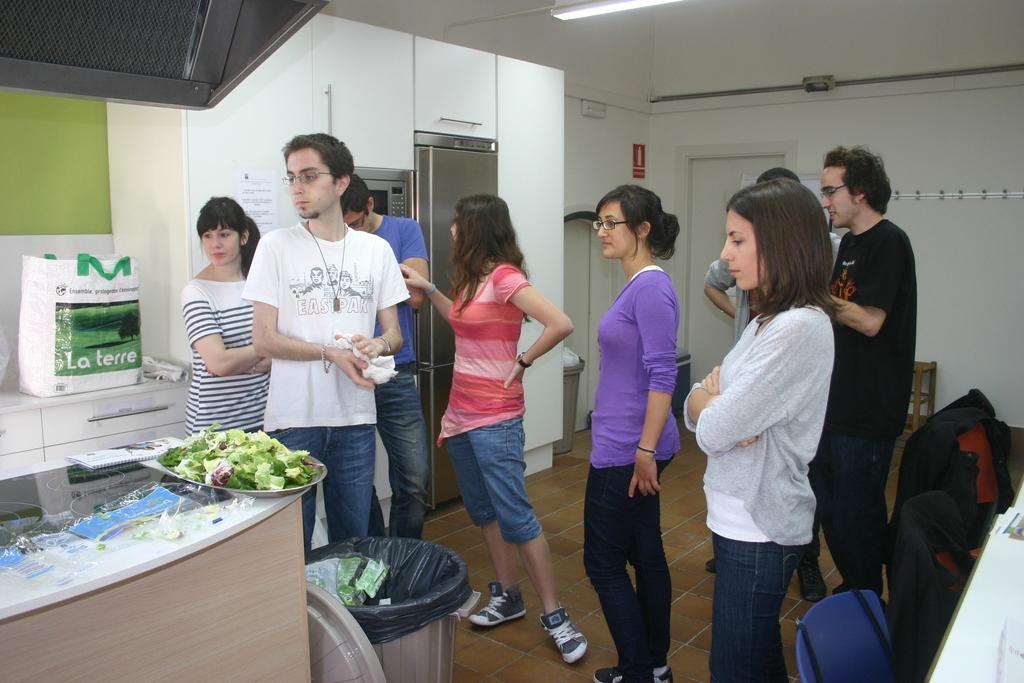Describe this image in one or two sentences. This picture is clicked inside the room. In this picture, we see many people are standing. In the right bottom of the picture, we see a white table and beside that, there are chairs. At the bottom of the picture, we see a garbage bin. Beside that, we see a table on which papers, book and a tray containing chopped vegetables are placed. Behind that, we see a white cupboard on which plastic bag is placed. Beside that, we see a white cupboard on which white poster is pasted. In the background, we see a white wall and a white door. 